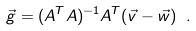Convert formula to latex. <formula><loc_0><loc_0><loc_500><loc_500>\vec { g } = ( A ^ { T } A ) ^ { - 1 } A ^ { T } ( \vec { v } - \vec { w } ) \ .</formula> 